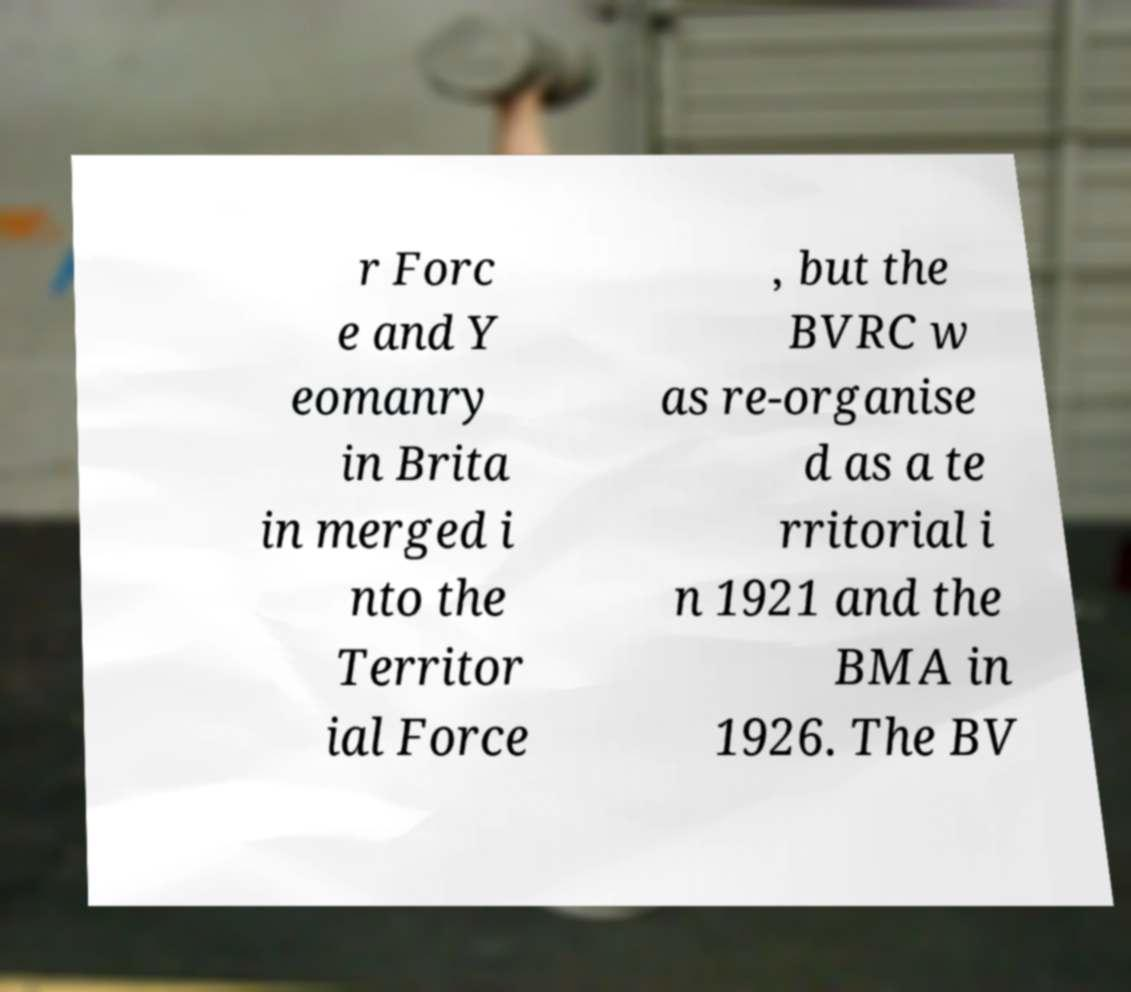Could you assist in decoding the text presented in this image and type it out clearly? r Forc e and Y eomanry in Brita in merged i nto the Territor ial Force , but the BVRC w as re-organise d as a te rritorial i n 1921 and the BMA in 1926. The BV 